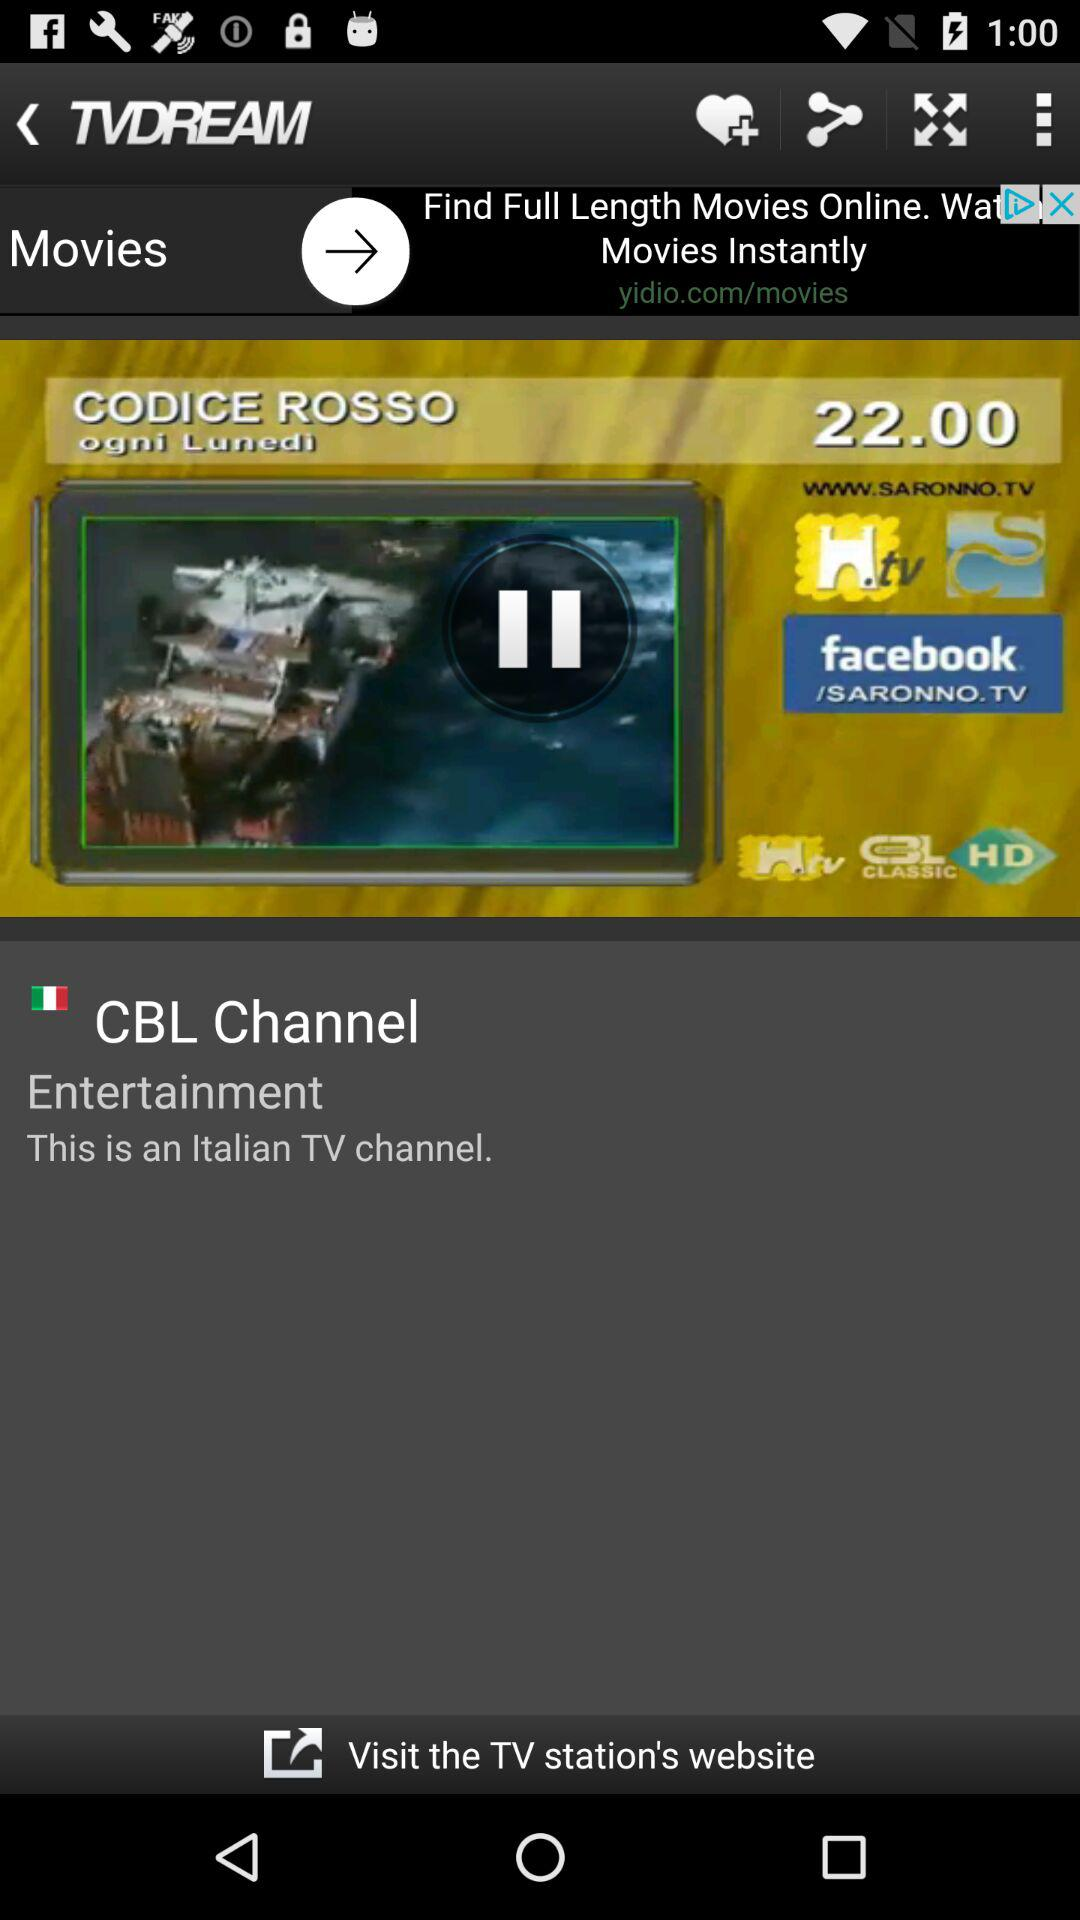What is the channel name? The channel name is "CBL Channel". 